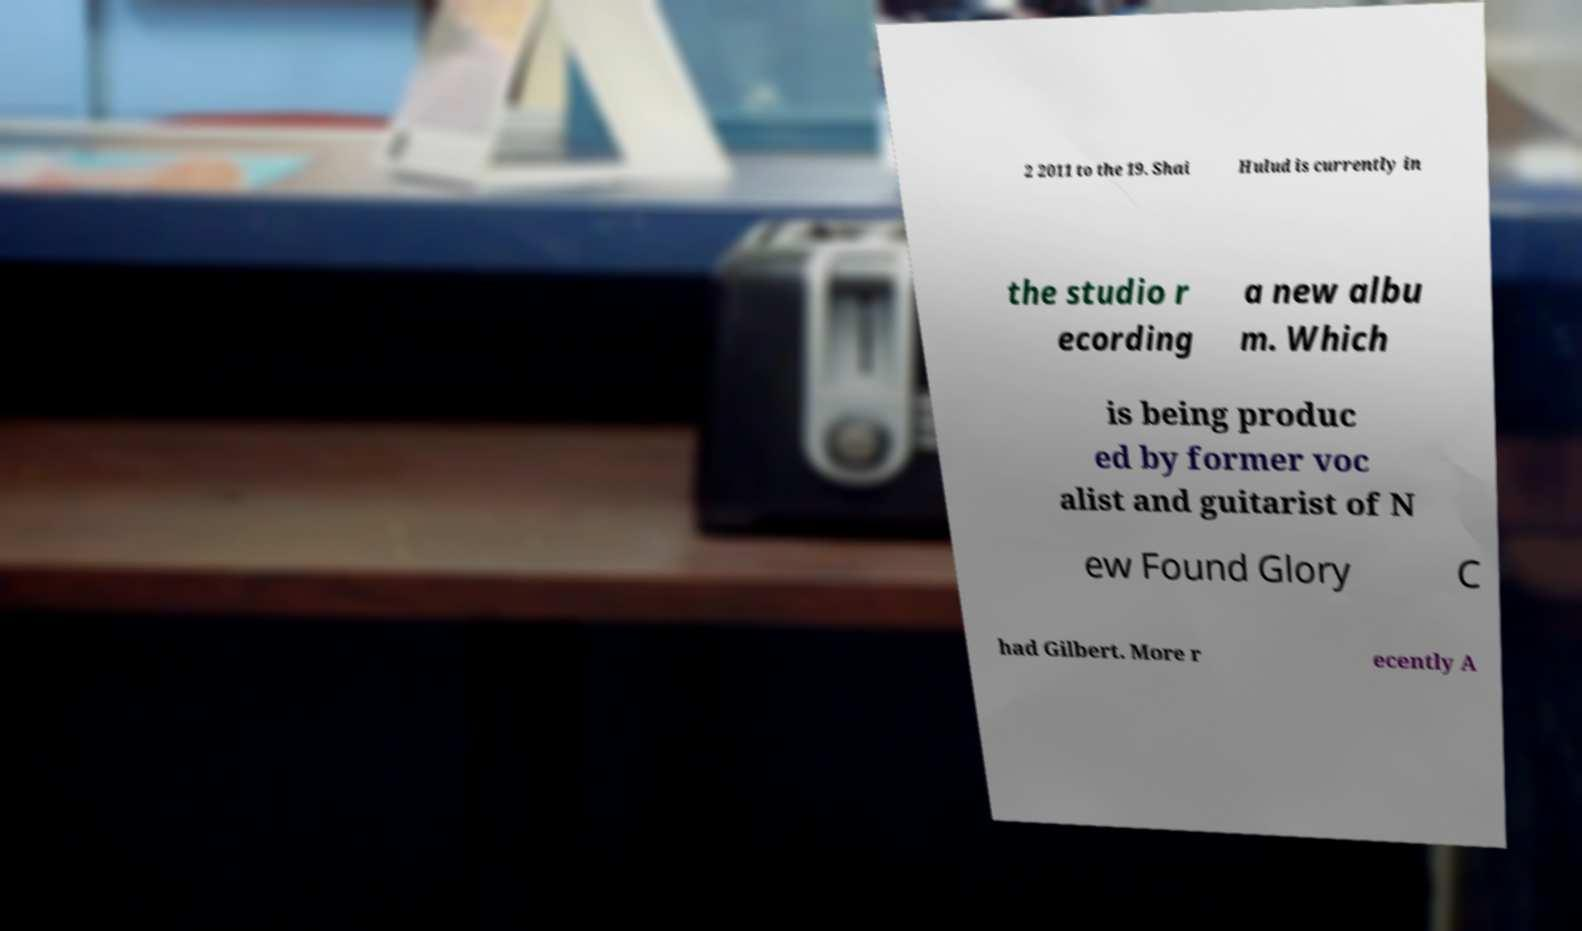There's text embedded in this image that I need extracted. Can you transcribe it verbatim? 2 2011 to the 19. Shai Hulud is currently in the studio r ecording a new albu m. Which is being produc ed by former voc alist and guitarist of N ew Found Glory C had Gilbert. More r ecently A 